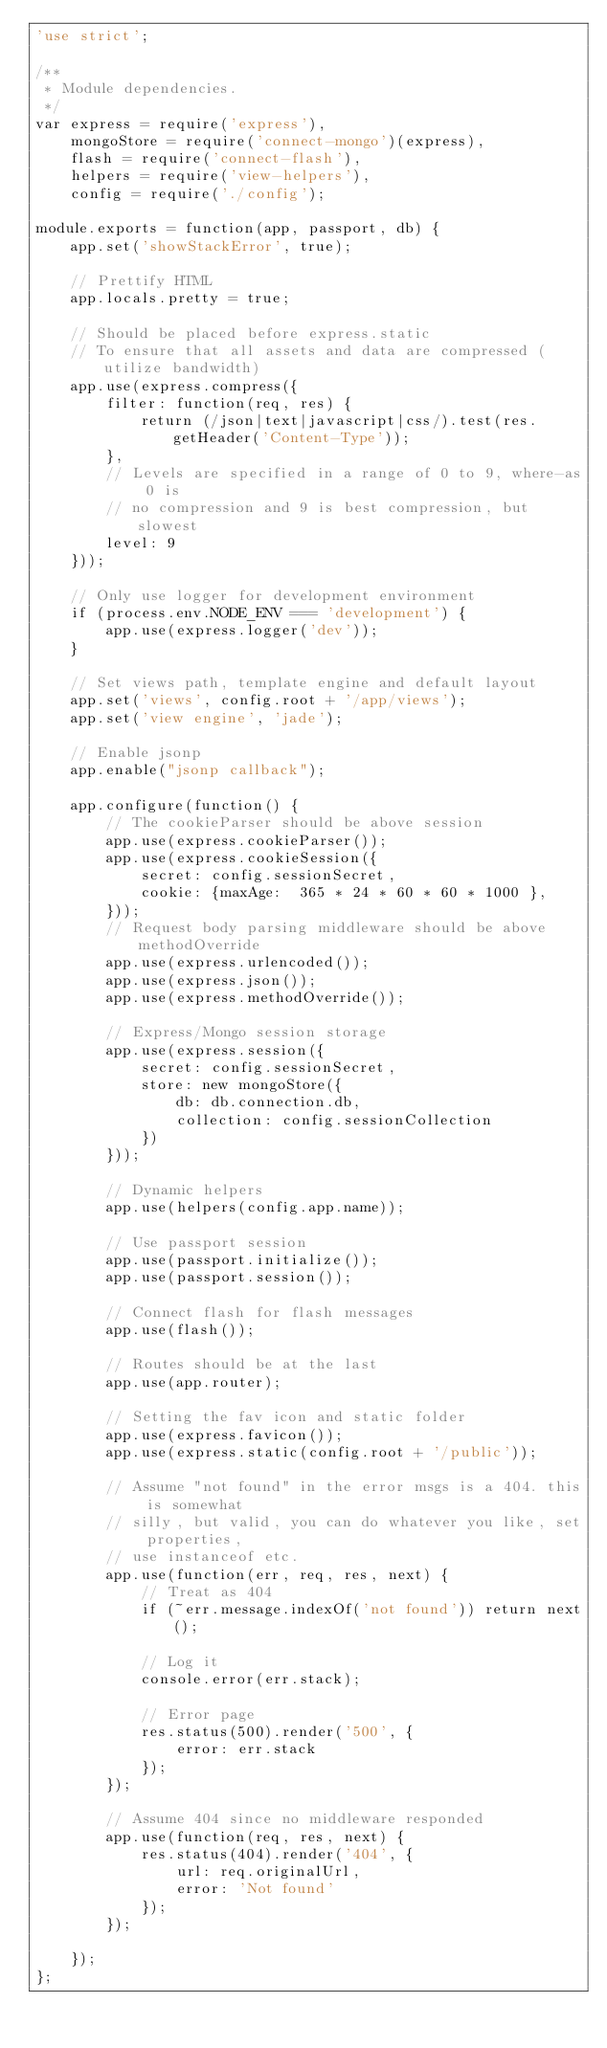Convert code to text. <code><loc_0><loc_0><loc_500><loc_500><_JavaScript_>'use strict';

/**
 * Module dependencies.
 */
var express = require('express'),
    mongoStore = require('connect-mongo')(express),
    flash = require('connect-flash'),
    helpers = require('view-helpers'),
    config = require('./config');

module.exports = function(app, passport, db) {
    app.set('showStackError', true);

    // Prettify HTML
    app.locals.pretty = true;

    // Should be placed before express.static
    // To ensure that all assets and data are compressed (utilize bandwidth)
    app.use(express.compress({
        filter: function(req, res) {
            return (/json|text|javascript|css/).test(res.getHeader('Content-Type'));
        },
        // Levels are specified in a range of 0 to 9, where-as 0 is
        // no compression and 9 is best compression, but slowest
        level: 9
    }));

    // Only use logger for development environment
    if (process.env.NODE_ENV === 'development') {
        app.use(express.logger('dev'));
    }

    // Set views path, template engine and default layout
    app.set('views', config.root + '/app/views');
    app.set('view engine', 'jade');

    // Enable jsonp
    app.enable("jsonp callback");

    app.configure(function() {
        // The cookieParser should be above session
        app.use(express.cookieParser());
		app.use(express.cookieSession({
			secret: config.sessionSecret, 
			cookie: {maxAge:  365 * 24 * 60 * 60 * 1000 },
		}));
        // Request body parsing middleware should be above methodOverride
        app.use(express.urlencoded());
        app.use(express.json());
        app.use(express.methodOverride());

        // Express/Mongo session storage
        app.use(express.session({
            secret: config.sessionSecret,
            store: new mongoStore({
                db: db.connection.db,
                collection: config.sessionCollection
            })
        }));

        // Dynamic helpers
        app.use(helpers(config.app.name));

        // Use passport session
        app.use(passport.initialize());
        app.use(passport.session());

        // Connect flash for flash messages
        app.use(flash());

        // Routes should be at the last
        app.use(app.router);
        
        // Setting the fav icon and static folder
        app.use(express.favicon());
        app.use(express.static(config.root + '/public'));

        // Assume "not found" in the error msgs is a 404. this is somewhat
        // silly, but valid, you can do whatever you like, set properties,
        // use instanceof etc.
        app.use(function(err, req, res, next) {
            // Treat as 404
            if (~err.message.indexOf('not found')) return next();

            // Log it
            console.error(err.stack);

            // Error page
            res.status(500).render('500', {
                error: err.stack
            });
        });

        // Assume 404 since no middleware responded
        app.use(function(req, res, next) {
            res.status(404).render('404', {
                url: req.originalUrl,
                error: 'Not found'
            });
        });

    });
};</code> 